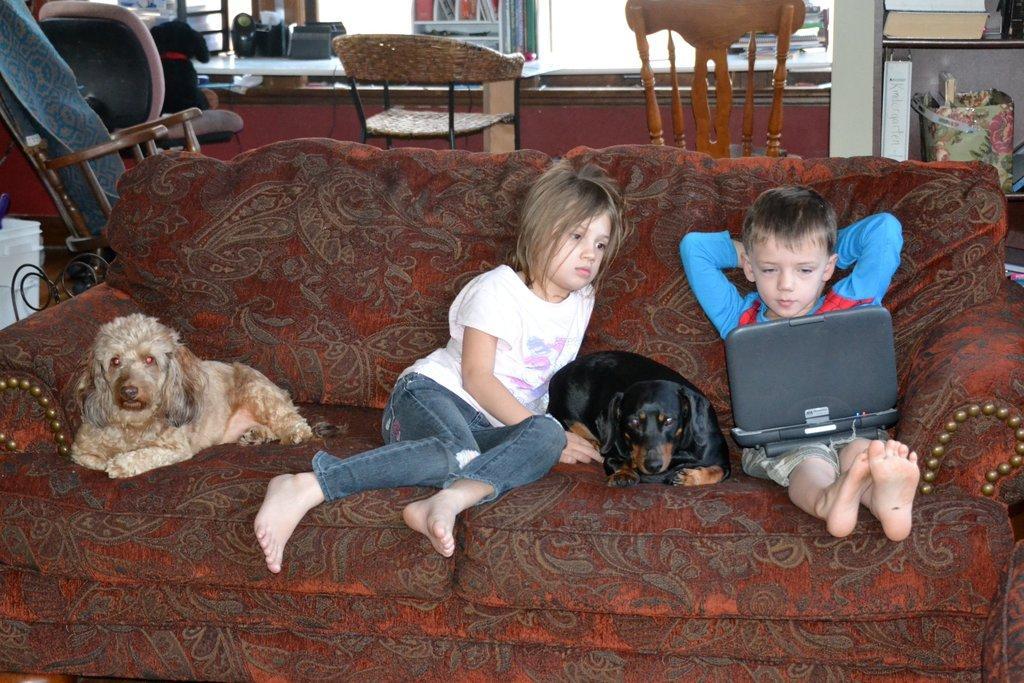Describe this image in one or two sentences. The person wearing a blue T-shirt is carrying a playing object and looking in to it and the person wearing white T-shirt is looking into the playing object and there are two dogs in the red sofa and there are also four chairs which are of different kind in the background. 